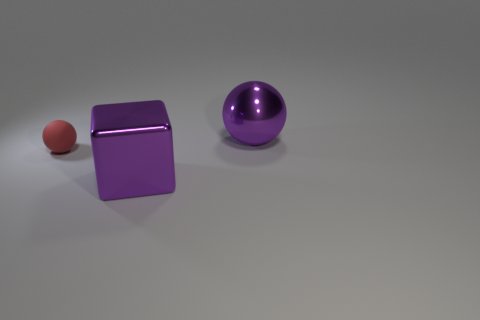Is the color of the ball on the right side of the tiny matte thing the same as the large metal thing in front of the tiny sphere?
Your answer should be compact. Yes. Is the material of the object that is behind the matte thing the same as the purple object left of the metallic sphere?
Your response must be concise. Yes. How big is the metallic object that is right of the big metallic cube?
Keep it short and to the point. Large. The purple metal block has what size?
Make the answer very short. Large. There is a cube that is left of the large metallic object behind the object on the left side of the big cube; what size is it?
Offer a very short reply. Large. Is there a red cylinder made of the same material as the red object?
Provide a short and direct response. No. The small red thing is what shape?
Your answer should be very brief. Sphere. There is a ball that is the same material as the large cube; what is its color?
Provide a short and direct response. Purple. How many yellow things are metallic things or large cubes?
Give a very brief answer. 0. Are there more small green metallic objects than purple things?
Offer a very short reply. No. 